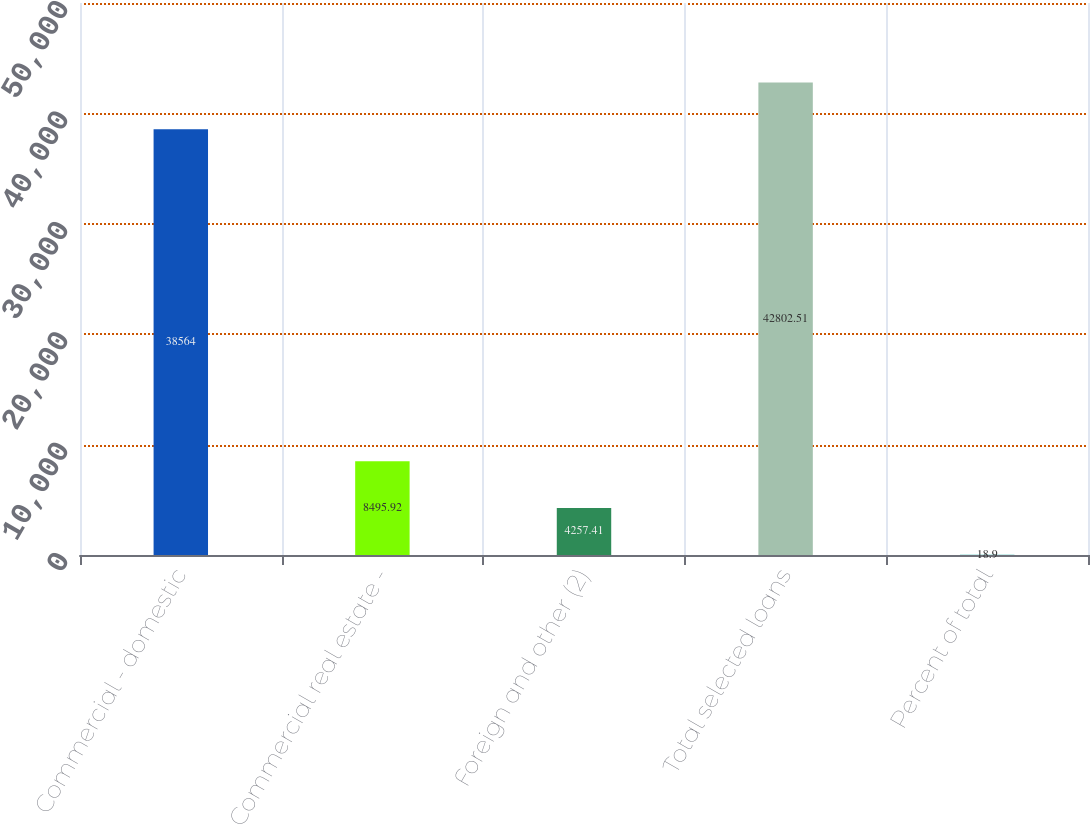Convert chart to OTSL. <chart><loc_0><loc_0><loc_500><loc_500><bar_chart><fcel>Commercial - domestic<fcel>Commercial real estate -<fcel>Foreign and other (2)<fcel>Total selected loans<fcel>Percent of total<nl><fcel>38564<fcel>8495.92<fcel>4257.41<fcel>42802.5<fcel>18.9<nl></chart> 